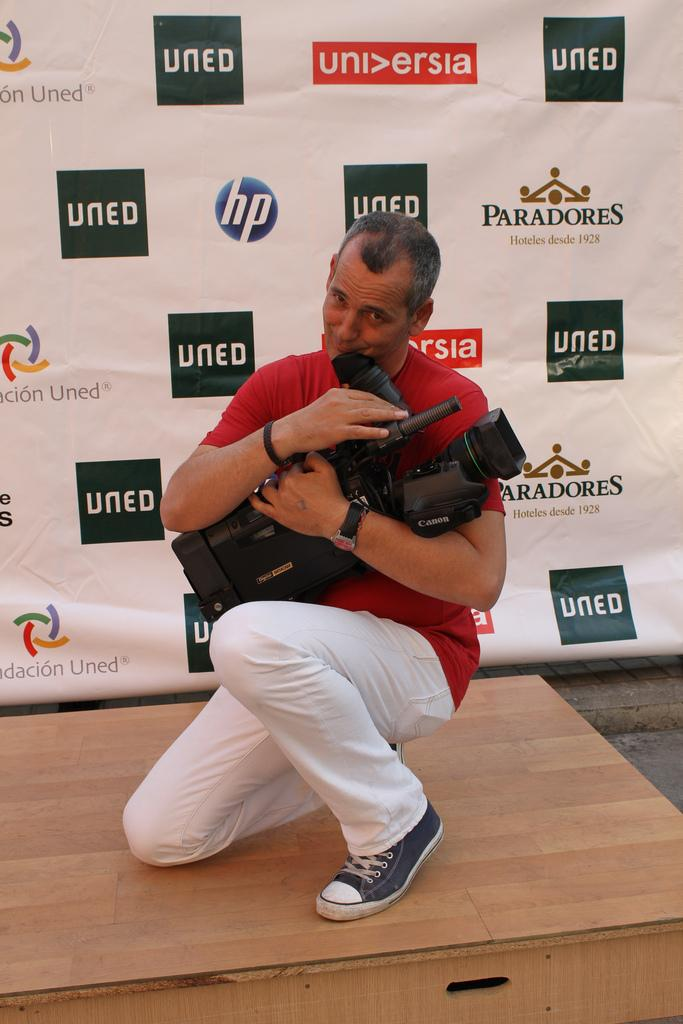<image>
Describe the image concisely. A man hugs his camera while crouching by a wall with a Paradores logo on it. 